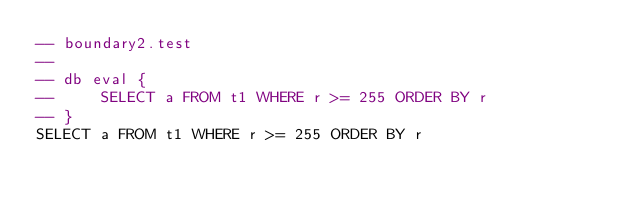<code> <loc_0><loc_0><loc_500><loc_500><_SQL_>-- boundary2.test
-- 
-- db eval {
--     SELECT a FROM t1 WHERE r >= 255 ORDER BY r
-- }
SELECT a FROM t1 WHERE r >= 255 ORDER BY r</code> 